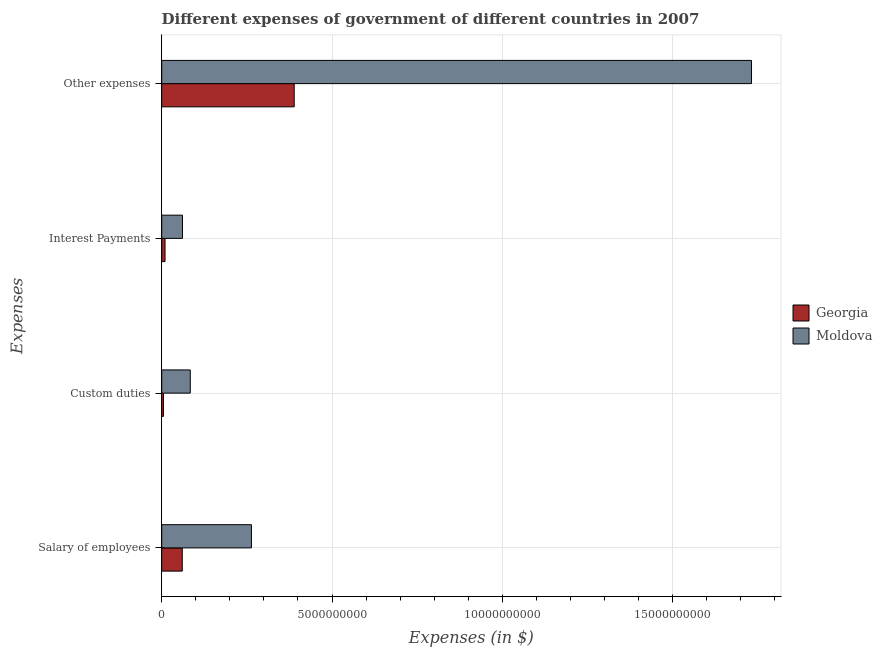How many groups of bars are there?
Keep it short and to the point. 4. How many bars are there on the 3rd tick from the bottom?
Give a very brief answer. 2. What is the label of the 3rd group of bars from the top?
Make the answer very short. Custom duties. What is the amount spent on custom duties in Georgia?
Keep it short and to the point. 5.20e+07. Across all countries, what is the maximum amount spent on custom duties?
Ensure brevity in your answer.  8.38e+08. Across all countries, what is the minimum amount spent on custom duties?
Provide a succinct answer. 5.20e+07. In which country was the amount spent on salary of employees maximum?
Offer a very short reply. Moldova. In which country was the amount spent on salary of employees minimum?
Ensure brevity in your answer.  Georgia. What is the total amount spent on custom duties in the graph?
Your response must be concise. 8.90e+08. What is the difference between the amount spent on other expenses in Georgia and that in Moldova?
Offer a terse response. -1.34e+1. What is the difference between the amount spent on interest payments in Moldova and the amount spent on custom duties in Georgia?
Your answer should be compact. 5.58e+08. What is the average amount spent on custom duties per country?
Offer a very short reply. 4.45e+08. What is the difference between the amount spent on other expenses and amount spent on custom duties in Moldova?
Provide a short and direct response. 1.65e+1. In how many countries, is the amount spent on interest payments greater than 17000000000 $?
Keep it short and to the point. 0. What is the ratio of the amount spent on custom duties in Moldova to that in Georgia?
Your response must be concise. 16.12. What is the difference between the highest and the second highest amount spent on salary of employees?
Offer a very short reply. 2.03e+09. What is the difference between the highest and the lowest amount spent on interest payments?
Offer a very short reply. 5.12e+08. In how many countries, is the amount spent on custom duties greater than the average amount spent on custom duties taken over all countries?
Offer a very short reply. 1. Is the sum of the amount spent on interest payments in Georgia and Moldova greater than the maximum amount spent on salary of employees across all countries?
Your answer should be compact. No. Is it the case that in every country, the sum of the amount spent on other expenses and amount spent on interest payments is greater than the sum of amount spent on salary of employees and amount spent on custom duties?
Provide a succinct answer. Yes. What does the 1st bar from the top in Other expenses represents?
Offer a terse response. Moldova. What does the 2nd bar from the bottom in Interest Payments represents?
Ensure brevity in your answer.  Moldova. How many bars are there?
Provide a succinct answer. 8. Are all the bars in the graph horizontal?
Ensure brevity in your answer.  Yes. What is the difference between two consecutive major ticks on the X-axis?
Make the answer very short. 5.00e+09. Does the graph contain any zero values?
Your answer should be compact. No. Where does the legend appear in the graph?
Your answer should be very brief. Center right. How many legend labels are there?
Provide a short and direct response. 2. What is the title of the graph?
Offer a very short reply. Different expenses of government of different countries in 2007. What is the label or title of the X-axis?
Keep it short and to the point. Expenses (in $). What is the label or title of the Y-axis?
Make the answer very short. Expenses. What is the Expenses (in $) of Georgia in Salary of employees?
Your answer should be compact. 6.04e+08. What is the Expenses (in $) of Moldova in Salary of employees?
Provide a succinct answer. 2.63e+09. What is the Expenses (in $) in Georgia in Custom duties?
Provide a succinct answer. 5.20e+07. What is the Expenses (in $) in Moldova in Custom duties?
Your answer should be very brief. 8.38e+08. What is the Expenses (in $) in Georgia in Interest Payments?
Give a very brief answer. 9.74e+07. What is the Expenses (in $) in Moldova in Interest Payments?
Keep it short and to the point. 6.10e+08. What is the Expenses (in $) of Georgia in Other expenses?
Your answer should be compact. 3.89e+09. What is the Expenses (in $) in Moldova in Other expenses?
Provide a short and direct response. 1.73e+1. Across all Expenses, what is the maximum Expenses (in $) of Georgia?
Make the answer very short. 3.89e+09. Across all Expenses, what is the maximum Expenses (in $) in Moldova?
Provide a succinct answer. 1.73e+1. Across all Expenses, what is the minimum Expenses (in $) in Georgia?
Give a very brief answer. 5.20e+07. Across all Expenses, what is the minimum Expenses (in $) in Moldova?
Your response must be concise. 6.10e+08. What is the total Expenses (in $) in Georgia in the graph?
Give a very brief answer. 4.64e+09. What is the total Expenses (in $) of Moldova in the graph?
Provide a short and direct response. 2.14e+1. What is the difference between the Expenses (in $) of Georgia in Salary of employees and that in Custom duties?
Ensure brevity in your answer.  5.52e+08. What is the difference between the Expenses (in $) in Moldova in Salary of employees and that in Custom duties?
Your answer should be compact. 1.80e+09. What is the difference between the Expenses (in $) in Georgia in Salary of employees and that in Interest Payments?
Give a very brief answer. 5.06e+08. What is the difference between the Expenses (in $) of Moldova in Salary of employees and that in Interest Payments?
Provide a succinct answer. 2.02e+09. What is the difference between the Expenses (in $) of Georgia in Salary of employees and that in Other expenses?
Offer a terse response. -3.29e+09. What is the difference between the Expenses (in $) of Moldova in Salary of employees and that in Other expenses?
Make the answer very short. -1.47e+1. What is the difference between the Expenses (in $) in Georgia in Custom duties and that in Interest Payments?
Give a very brief answer. -4.54e+07. What is the difference between the Expenses (in $) in Moldova in Custom duties and that in Interest Payments?
Provide a succinct answer. 2.29e+08. What is the difference between the Expenses (in $) of Georgia in Custom duties and that in Other expenses?
Your response must be concise. -3.84e+09. What is the difference between the Expenses (in $) in Moldova in Custom duties and that in Other expenses?
Offer a terse response. -1.65e+1. What is the difference between the Expenses (in $) in Georgia in Interest Payments and that in Other expenses?
Your response must be concise. -3.79e+09. What is the difference between the Expenses (in $) in Moldova in Interest Payments and that in Other expenses?
Offer a terse response. -1.67e+1. What is the difference between the Expenses (in $) of Georgia in Salary of employees and the Expenses (in $) of Moldova in Custom duties?
Make the answer very short. -2.35e+08. What is the difference between the Expenses (in $) of Georgia in Salary of employees and the Expenses (in $) of Moldova in Interest Payments?
Offer a very short reply. -6.30e+06. What is the difference between the Expenses (in $) in Georgia in Salary of employees and the Expenses (in $) in Moldova in Other expenses?
Provide a short and direct response. -1.67e+1. What is the difference between the Expenses (in $) in Georgia in Custom duties and the Expenses (in $) in Moldova in Interest Payments?
Give a very brief answer. -5.58e+08. What is the difference between the Expenses (in $) of Georgia in Custom duties and the Expenses (in $) of Moldova in Other expenses?
Ensure brevity in your answer.  -1.73e+1. What is the difference between the Expenses (in $) of Georgia in Interest Payments and the Expenses (in $) of Moldova in Other expenses?
Give a very brief answer. -1.72e+1. What is the average Expenses (in $) of Georgia per Expenses?
Keep it short and to the point. 1.16e+09. What is the average Expenses (in $) in Moldova per Expenses?
Offer a terse response. 5.35e+09. What is the difference between the Expenses (in $) of Georgia and Expenses (in $) of Moldova in Salary of employees?
Keep it short and to the point. -2.03e+09. What is the difference between the Expenses (in $) in Georgia and Expenses (in $) in Moldova in Custom duties?
Give a very brief answer. -7.86e+08. What is the difference between the Expenses (in $) in Georgia and Expenses (in $) in Moldova in Interest Payments?
Your answer should be compact. -5.12e+08. What is the difference between the Expenses (in $) of Georgia and Expenses (in $) of Moldova in Other expenses?
Keep it short and to the point. -1.34e+1. What is the ratio of the Expenses (in $) of Georgia in Salary of employees to that in Custom duties?
Ensure brevity in your answer.  11.61. What is the ratio of the Expenses (in $) of Moldova in Salary of employees to that in Custom duties?
Keep it short and to the point. 3.14. What is the ratio of the Expenses (in $) in Georgia in Salary of employees to that in Interest Payments?
Provide a short and direct response. 6.2. What is the ratio of the Expenses (in $) in Moldova in Salary of employees to that in Interest Payments?
Provide a short and direct response. 4.32. What is the ratio of the Expenses (in $) of Georgia in Salary of employees to that in Other expenses?
Make the answer very short. 0.16. What is the ratio of the Expenses (in $) of Moldova in Salary of employees to that in Other expenses?
Your answer should be compact. 0.15. What is the ratio of the Expenses (in $) of Georgia in Custom duties to that in Interest Payments?
Give a very brief answer. 0.53. What is the ratio of the Expenses (in $) in Moldova in Custom duties to that in Interest Payments?
Provide a succinct answer. 1.38. What is the ratio of the Expenses (in $) of Georgia in Custom duties to that in Other expenses?
Keep it short and to the point. 0.01. What is the ratio of the Expenses (in $) in Moldova in Custom duties to that in Other expenses?
Provide a short and direct response. 0.05. What is the ratio of the Expenses (in $) of Georgia in Interest Payments to that in Other expenses?
Ensure brevity in your answer.  0.03. What is the ratio of the Expenses (in $) of Moldova in Interest Payments to that in Other expenses?
Provide a short and direct response. 0.04. What is the difference between the highest and the second highest Expenses (in $) in Georgia?
Keep it short and to the point. 3.29e+09. What is the difference between the highest and the second highest Expenses (in $) of Moldova?
Ensure brevity in your answer.  1.47e+1. What is the difference between the highest and the lowest Expenses (in $) of Georgia?
Offer a terse response. 3.84e+09. What is the difference between the highest and the lowest Expenses (in $) in Moldova?
Make the answer very short. 1.67e+1. 